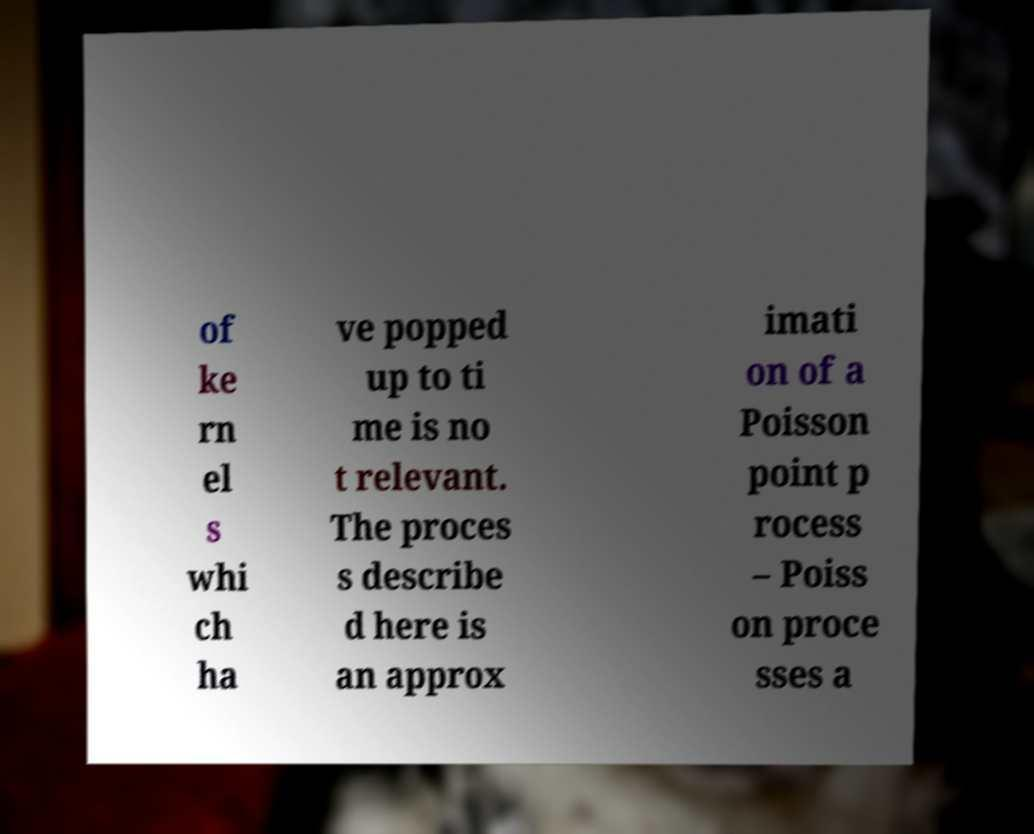I need the written content from this picture converted into text. Can you do that? of ke rn el s whi ch ha ve popped up to ti me is no t relevant. The proces s describe d here is an approx imati on of a Poisson point p rocess – Poiss on proce sses a 